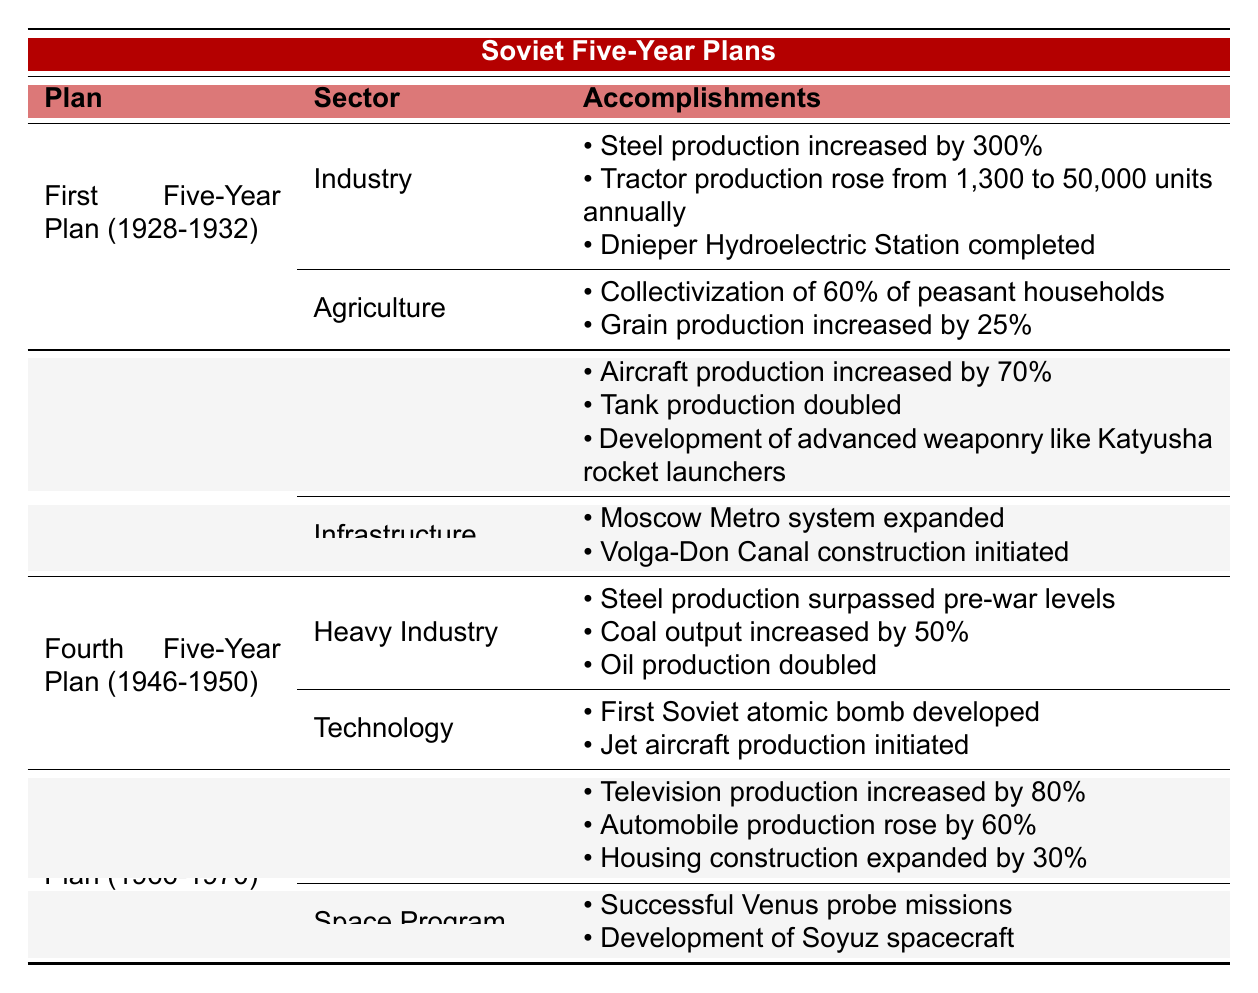What were the major accomplishments in the industrial sector during the First Five-Year Plan? The Industrial sector accomplishments listed under the First Five-Year Plan include a 300% increase in steel production, raising tractor production from 1,300 to 50,000 units annually, and the completion of the Dnieper Hydroelectric Station.
Answer: Steel production increased by 300%, tractor production rose to 50,000 units, Dnieper Hydroelectric Station completed Which Five-Year Plan focused on defense sector achievements? The Third Five-Year Plan (1938-1941) focused on the defense sector, showcasing accomplishments like a 70% increase in aircraft production, a doubling of tank production, and the development of advanced weaponry such as Katyusha rocket launchers.
Answer: Third Five-Year Plan (1938-1941) How much did coal output increase during the Fourth Five-Year Plan? According to the Fourth Five-Year Plan, coal output increased by 50%.
Answer: Coal output increased by 50% What was the result of the agricultural achievements in the First Five-Year Plan? The agricultural sector accomplishments during the First Five-Year Plan included the collectivization of 60% of peasant households and a 25% increase in grain production.
Answer: Collectivization of 60% of households; grain production increased by 25% Which sector experienced the most significant growth in the Eighth Five-Year Plan based on production values? The consumer goods sector in the Eighth Five-Year Plan showed significant growth with television production increasing by 80% and automobile production rising by 60%.
Answer: Consumer goods sector Did the Fourth Five-Year Plan contribute to technological advancements? Yes, the Fourth Five-Year Plan contributed to technological advancements, including the development of the first Soviet atomic bomb and the initiation of jet aircraft production.
Answer: Yes Compare the steel production increase in the First and Fourth Five-Year Plans. In the First Five-Year Plan, steel production increased by 300%, while the Fourth Five-Year Plan stated that steel production surpassed pre-war levels. Although the exact percentage increase in the Fourth Plan is not given, it indicates recovery and growth post-war.
Answer: First Plan: 300%; Fourth Plan: surpassed pre-war levels What initiatives were taken for infrastructural development during the Third Five-Year Plan? In the Third Five-Year Plan, infrastructural development initiatives included the expansion of the Moscow Metro system and the initiation of the Volga-Don Canal construction.
Answer: Moscow Metro expanded; Volga-Don Canal initiated Identify the achievements of the space program during the Eighth Five-Year Plan. The space program during the Eighth Five-Year Plan achieved successful Venus probe missions and the development of Soyuz spacecraft.
Answer: Venus probe missions; Soyuz spacecraft development How did the accomplishments in the defense sector during the Third Five-Year Plan affect military production? The accomplishments in the defense sector, such as a 70% increase in aircraft production and doubling of tank production, significantly enhanced military production capability during that period.
Answer: Enhanced military production 